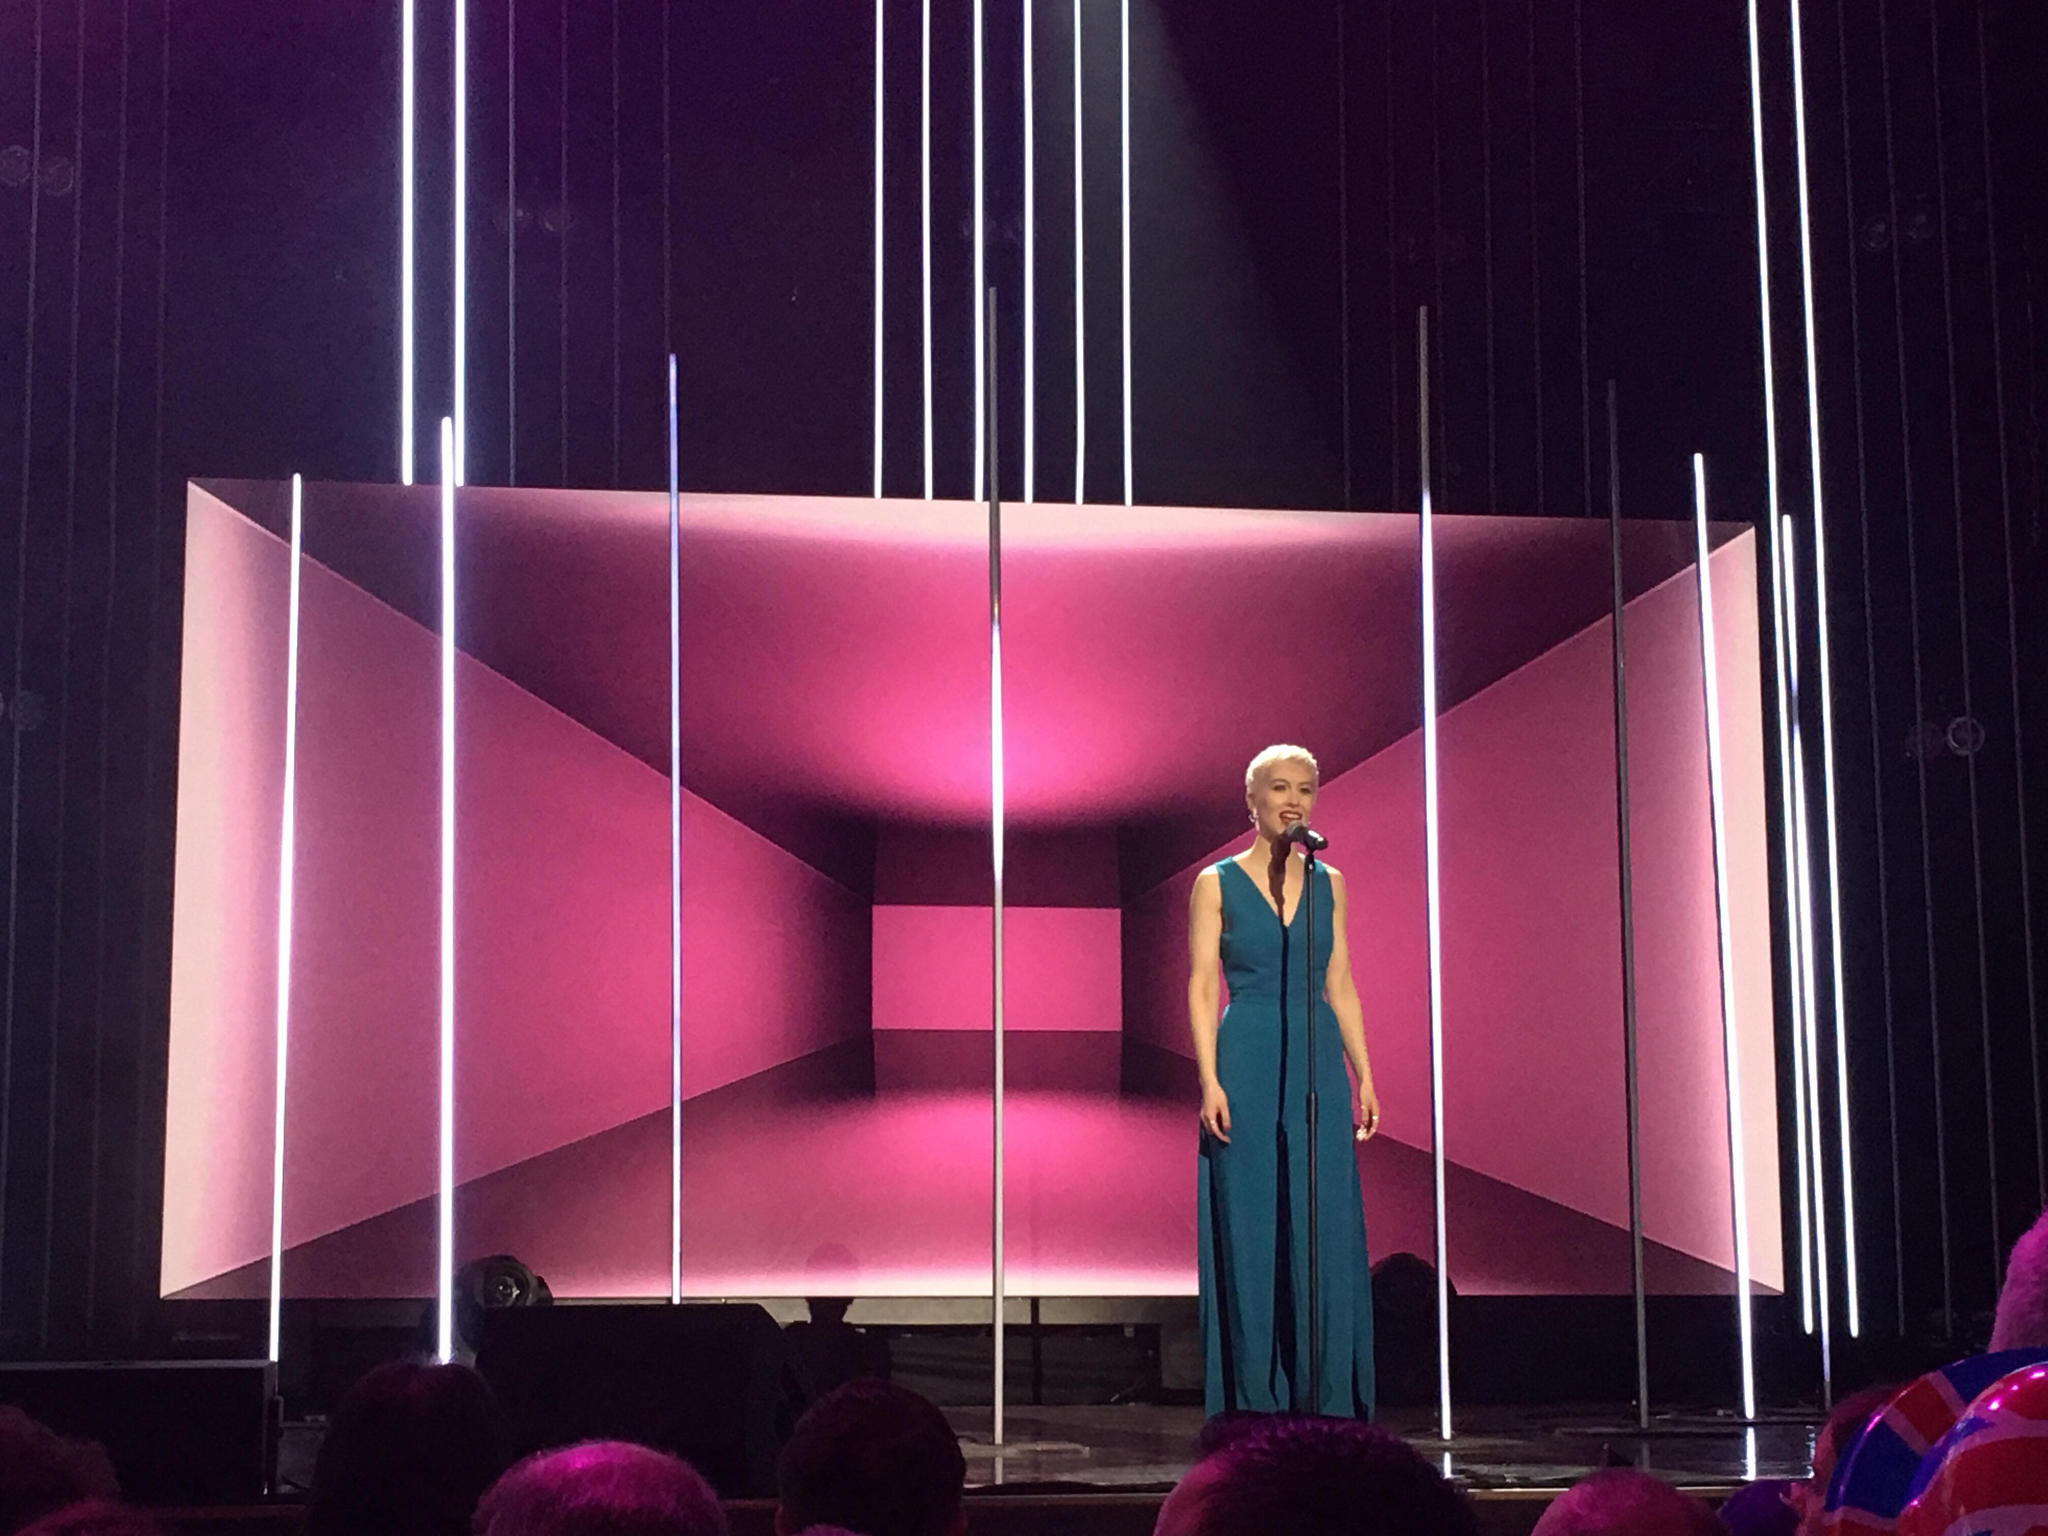What role do lighting colors play in influencing the audience's perception of the performance? Lighting colors play a crucial role in staging by setting the emotional tone and atmosphere. In this image, the interplay of pink and purple suggests a blend of subtle energy and reflective calm, which can evoke different emotional responses such as tranquility mixed with anticipation. The careful selection of these hues might be aimed at guiding the audience's emotional journey throughout the performance. 